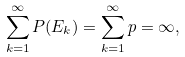<formula> <loc_0><loc_0><loc_500><loc_500>\sum _ { k = 1 } ^ { \infty } P ( E _ { k } ) = \sum _ { k = 1 } ^ { \infty } p = \infty ,</formula> 